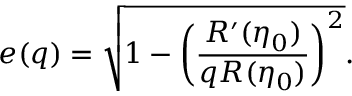<formula> <loc_0><loc_0><loc_500><loc_500>e ( q ) = \sqrt { 1 - \left ( \frac { R ^ { \prime } ( \eta _ { 0 } ) } { q R ( \eta _ { 0 } ) } \right ) ^ { 2 } } .</formula> 